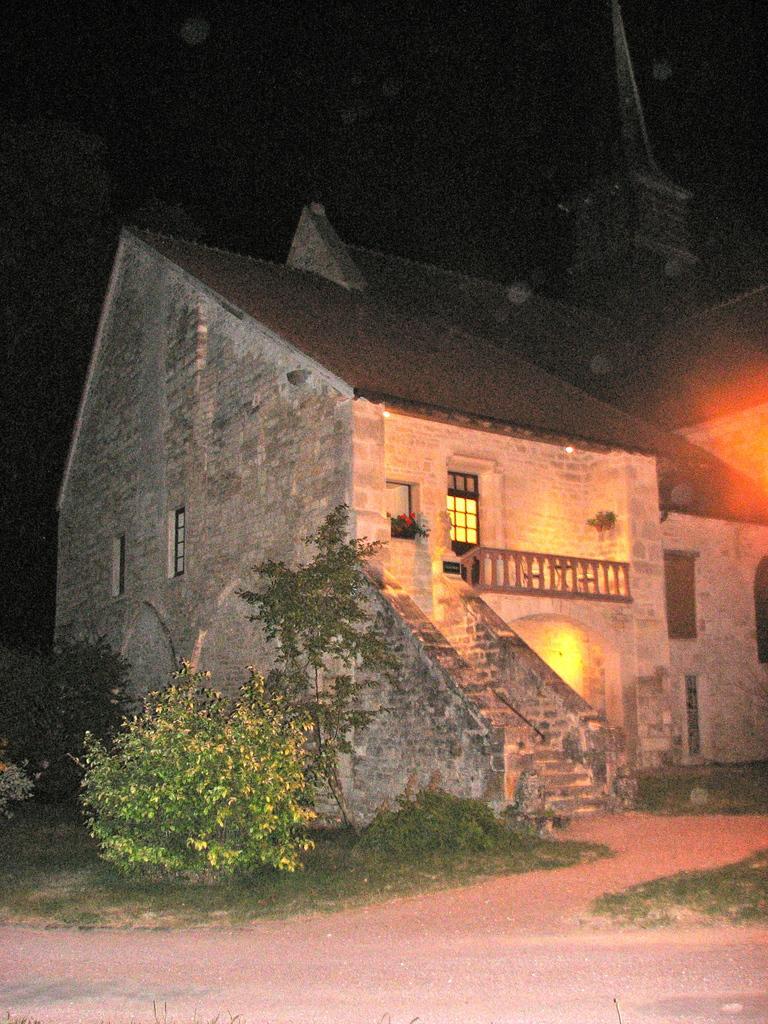In one or two sentences, can you explain what this image depicts? In this image there is a building, in front of the building there are trees, plants, grass and the sky. 